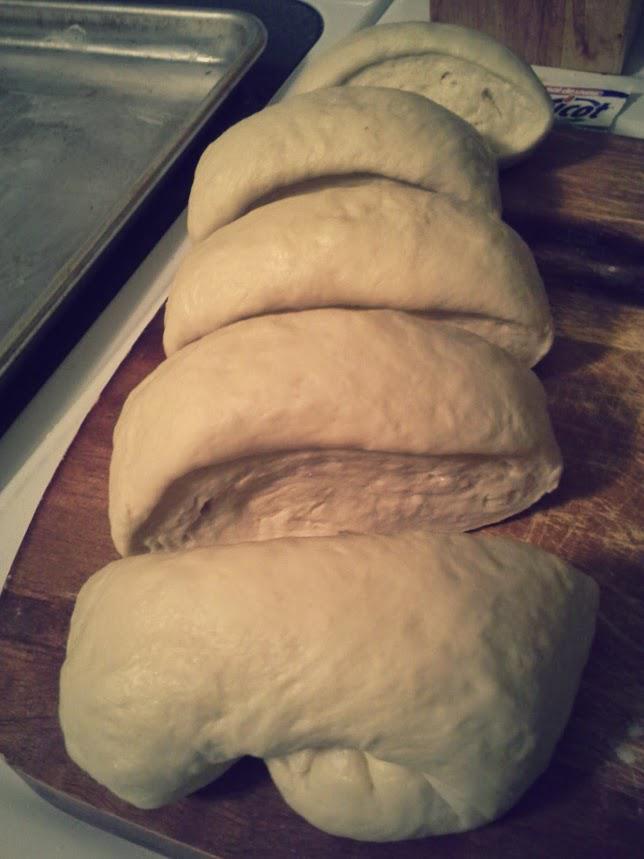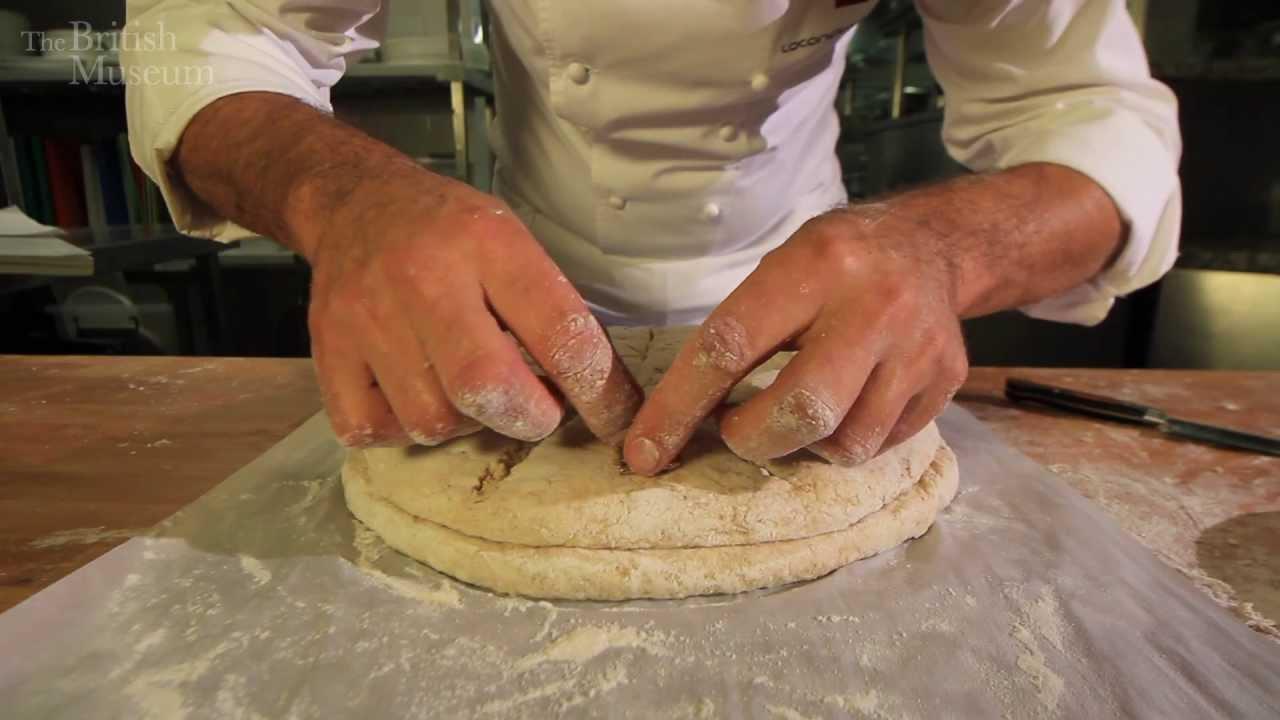The first image is the image on the left, the second image is the image on the right. Assess this claim about the two images: "There are no wooden utensils present.". Correct or not? Answer yes or no. Yes. The first image is the image on the left, the second image is the image on the right. Given the left and right images, does the statement "The right image shows a pair of hands with fingers touching flattened dough on floured wood," hold true? Answer yes or no. Yes. 